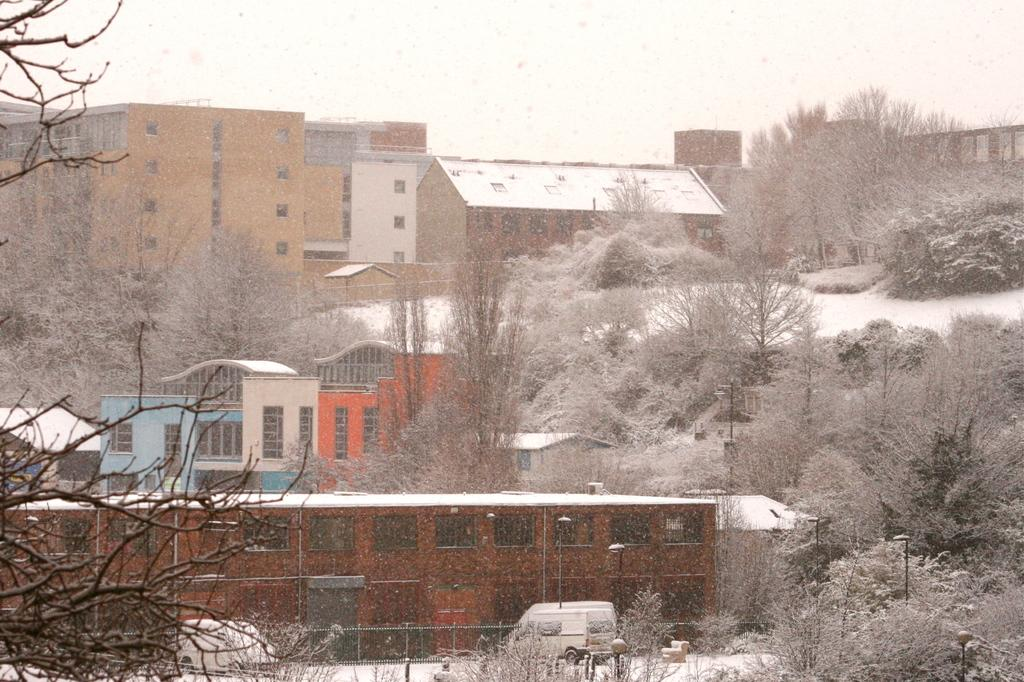What type of structures can be seen in the image? There are buildings in the image. What other natural elements are present in the image? There are trees in the image. What feature of the buildings can be seen in the image? There are windows visible in the image. What else is present in the image besides buildings and trees? Vehicles and poles are visible in the image. Are there any illumination sources in the image? Yes, lights are present in the image. What part of the natural environment is visible in the image? The sky is visible in the image. Can you see a ladybug crawling on the observation deck in the image? There is no observation deck or ladybug present in the image. What type of pail is being used to collect rainwater in the image? There is no pail or rainwater collection in the image. 